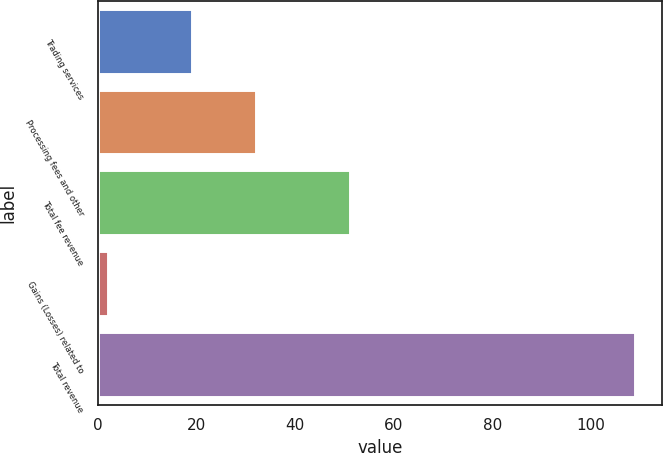Convert chart to OTSL. <chart><loc_0><loc_0><loc_500><loc_500><bar_chart><fcel>Trading services<fcel>Processing fees and other<fcel>Total fee revenue<fcel>Gains (Losses) related to<fcel>Total revenue<nl><fcel>19<fcel>32<fcel>51<fcel>2<fcel>109<nl></chart> 